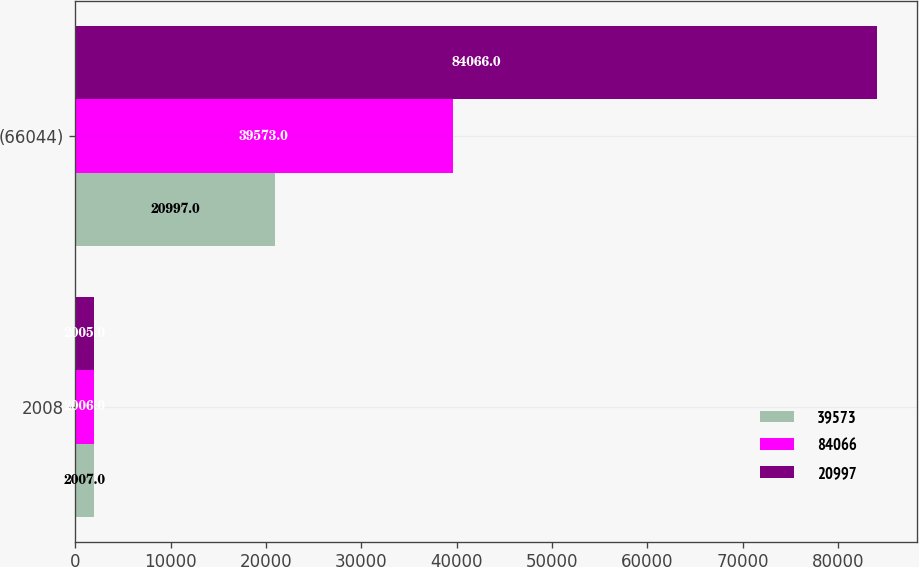<chart> <loc_0><loc_0><loc_500><loc_500><stacked_bar_chart><ecel><fcel>2008<fcel>(66044)<nl><fcel>39573<fcel>2007<fcel>20997<nl><fcel>84066<fcel>2006<fcel>39573<nl><fcel>20997<fcel>2005<fcel>84066<nl></chart> 